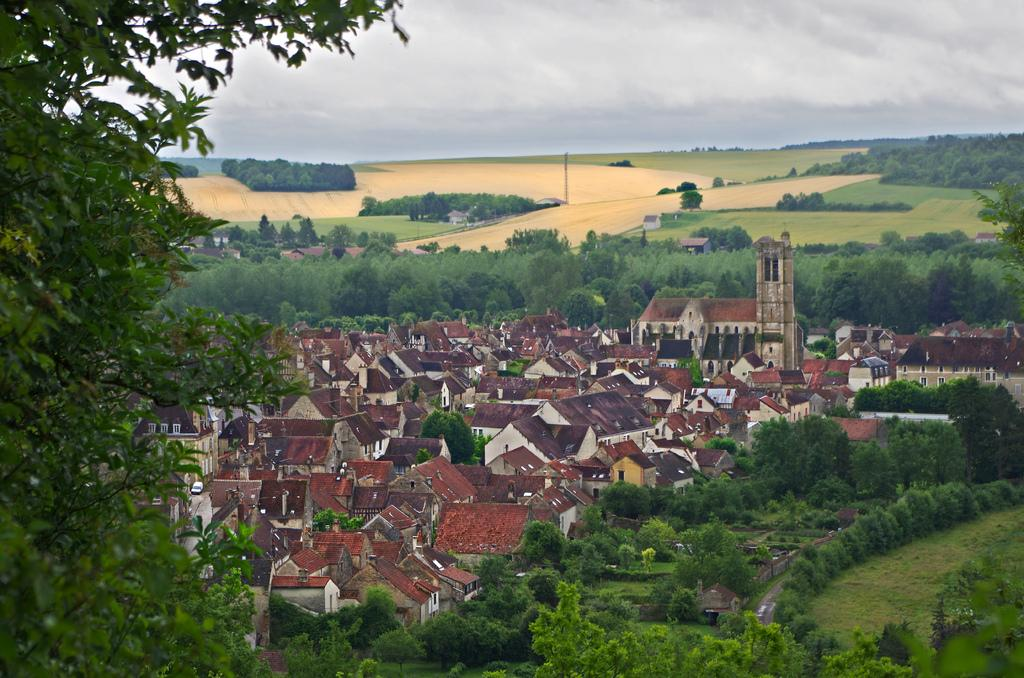What is located at the bottom of the image? There are houses, trees, plants, and grass at the bottom of the image. What can be seen in the middle of the image? There are crops and trees in the middle of the image, along with the sky. What is visible in the sky in the image? The sky is visible in the middle of the image, and there are clouds present. What type of scent can be detected from the lizards in the image? There are no lizards present in the image, so it is not possible to detect any scent from them. 